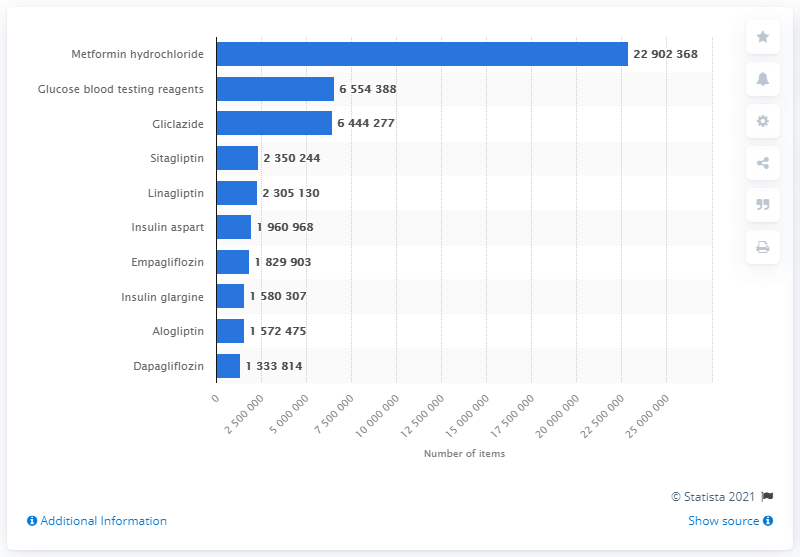Indicate a few pertinent items in this graphic. In 2020, a total of 229,023,680 units of metformin hydrochloride were dispensed. 